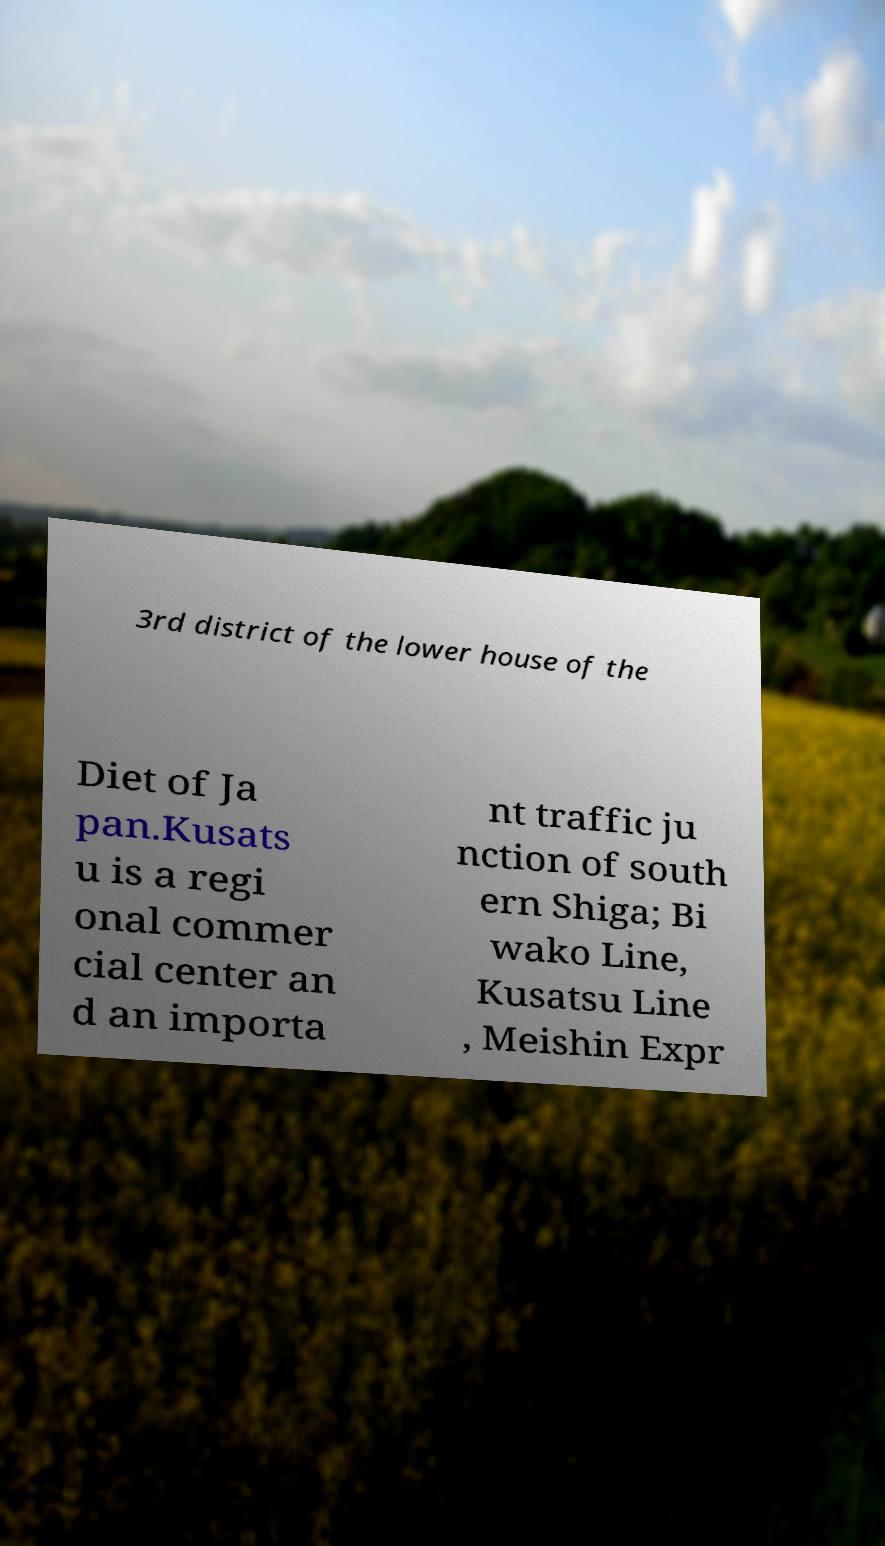Could you assist in decoding the text presented in this image and type it out clearly? 3rd district of the lower house of the Diet of Ja pan.Kusats u is a regi onal commer cial center an d an importa nt traffic ju nction of south ern Shiga; Bi wako Line, Kusatsu Line , Meishin Expr 